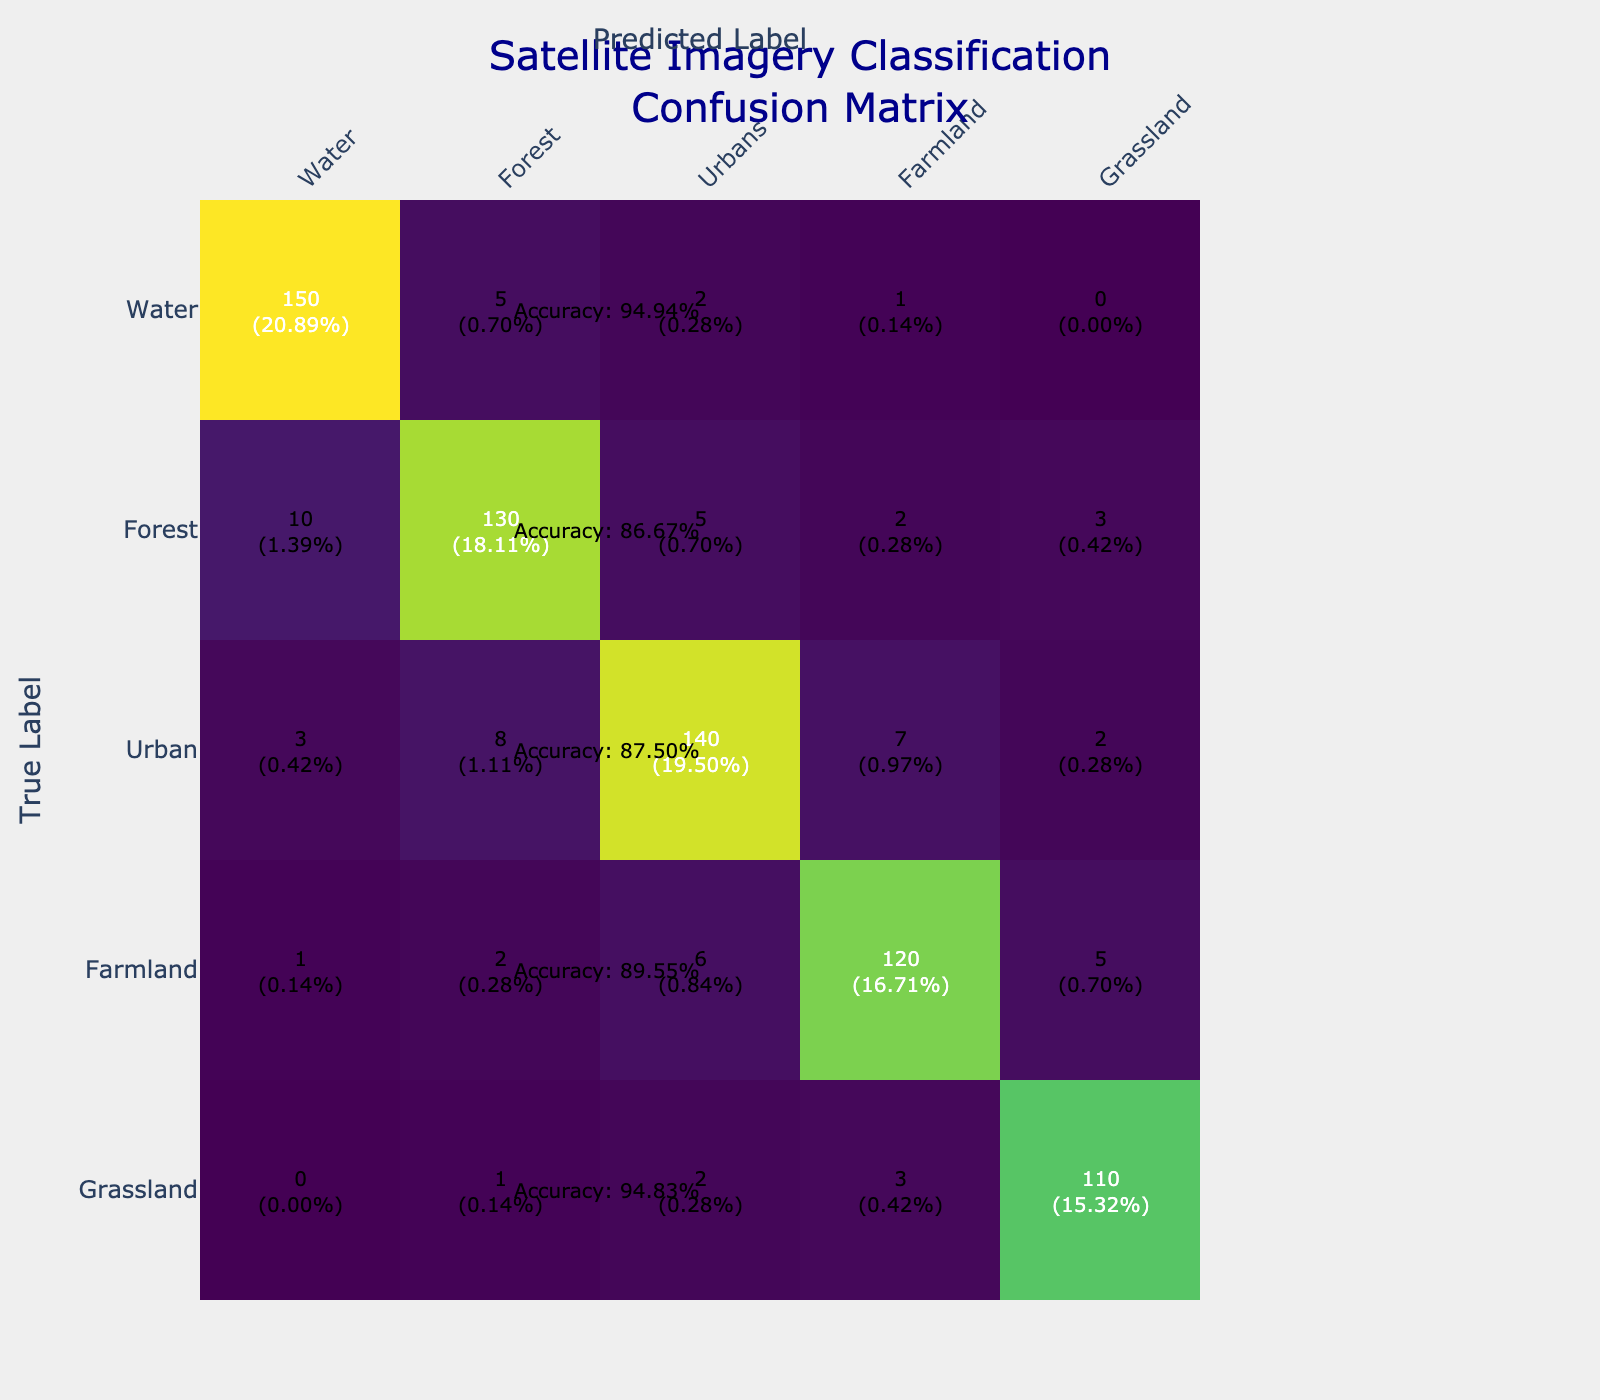What is the number of true positives for Water? The number of true positives for Water is represented by the cell where the True Label is Water and it is predicted as Water. This corresponds to 150 in the table.
Answer: 150 What is the accuracy of the Urban classification? To find the accuracy for Urban, we look at the values in the Urban row. The true positives for Urban is 140, the total for that row is (3 + 8 + 140 + 7 + 2) = 160. Accuracy is calculated as true positives divided by total: 140/160 = 0.875, or 87.5%.
Answer: 87.5% Is the number of misclassifications for Grassland greater than that for Water? To determine this, we need to look at the off-diagonal values for both Grassland and Water. Grassland's misclassifications are (0 + 1 + 2 + 3) = 6, while Water's misclassifications are (5 + 2 + 1 + 0) = 8. Since 6 is less than 8, the answer is no.
Answer: No What is the total number of misclassifications for Farmland? In the Farmland row, the misclassifications are the sum of the values in the Farmland row excluding the true positive. This can be calculated as (1 + 2 + 6 + 5) = 14.
Answer: 14 How many total classifications were made for Forest? To find the total classifications for Forest, we sum all the values in the Forest row: (10 + 130 + 5 + 2 + 3) = 150.
Answer: 150 What is the total number of predicted classifications for Urban that were incorrectly classified into other categories? We need to sum the values in the Urban row except for the true positive: (3 + 8 + 7 + 2) = 20.
Answer: 20 Which land cover type had the highest number of true positives? By examining the true positive values along the diagonal of the table, we see Water has 150, Forest has 130, Urban has 140, Farmland has 120, and Grassland has 110. Thus, Water has the highest true positives.
Answer: Water What is the overall total number of satellite imagery classifications made? The overall total can be calculated by summing all values in the confusion matrix. Total = (150 + 5 + 2 + 1 + 0) + (10 + 130 + 5 + 2 + 3) + (3 + 8 + 140 + 7 + 2) + (1 + 2 + 6 + 120 + 5) + (0 + 1 + 2 + 3 + 110) = 480.
Answer: 480 What is the AVE (average error rate) for all land cover classifications? To find the average error rate, we first need the total errors. Total errors = (5 + 2 + 1 + 0) + (10 + 5 + 2 + 3) + (3 + 8 + 7 + 2) + (1 + 2 + 6 + 5) + (0 + 1 + 2 + 3) = 66. The total classifications made is 480. So the average error rate is 66/480 = 0.1375 or 13.75%.
Answer: 13.75% 